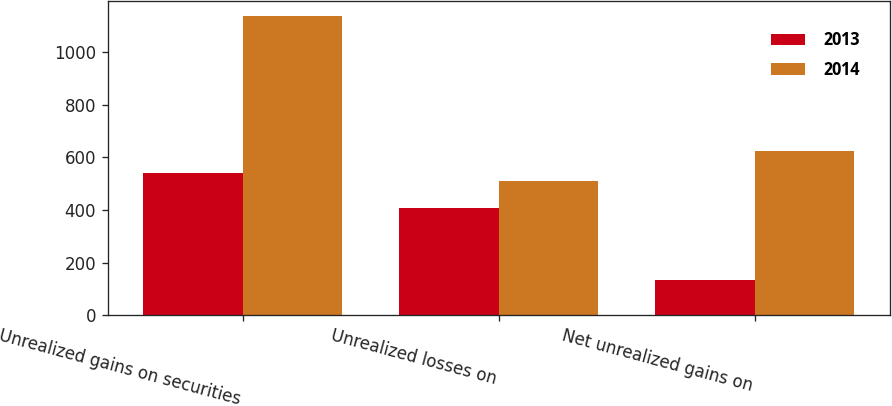Convert chart. <chart><loc_0><loc_0><loc_500><loc_500><stacked_bar_chart><ecel><fcel>Unrealized gains on securities<fcel>Unrealized losses on<fcel>Net unrealized gains on<nl><fcel>2013<fcel>541<fcel>407<fcel>134<nl><fcel>2014<fcel>1137<fcel>511<fcel>626<nl></chart> 